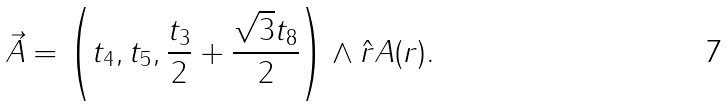Convert formula to latex. <formula><loc_0><loc_0><loc_500><loc_500>\vec { A } = \left ( t _ { 4 } , t _ { 5 } , \frac { t _ { 3 } } { 2 } + \frac { \sqrt { 3 } t _ { 8 } } { 2 } \right ) \wedge \hat { r } A ( r ) . \quad</formula> 